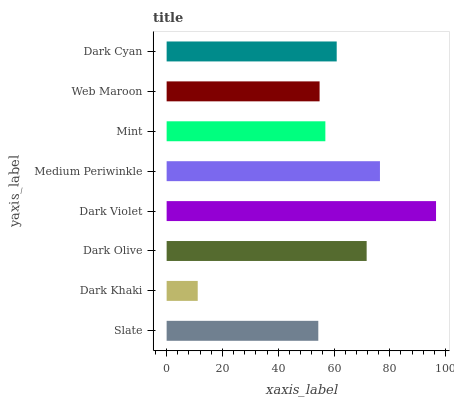Is Dark Khaki the minimum?
Answer yes or no. Yes. Is Dark Violet the maximum?
Answer yes or no. Yes. Is Dark Olive the minimum?
Answer yes or no. No. Is Dark Olive the maximum?
Answer yes or no. No. Is Dark Olive greater than Dark Khaki?
Answer yes or no. Yes. Is Dark Khaki less than Dark Olive?
Answer yes or no. Yes. Is Dark Khaki greater than Dark Olive?
Answer yes or no. No. Is Dark Olive less than Dark Khaki?
Answer yes or no. No. Is Dark Cyan the high median?
Answer yes or no. Yes. Is Mint the low median?
Answer yes or no. Yes. Is Mint the high median?
Answer yes or no. No. Is Dark Olive the low median?
Answer yes or no. No. 